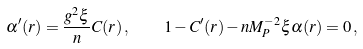<formula> <loc_0><loc_0><loc_500><loc_500>\alpha ^ { \prime } ( r ) = \frac { g ^ { 2 } \xi } { n } C ( r ) \, , \quad 1 - C ^ { \prime } ( r ) - n M _ { P } ^ { - 2 } \xi \alpha ( r ) = 0 \, ,</formula> 